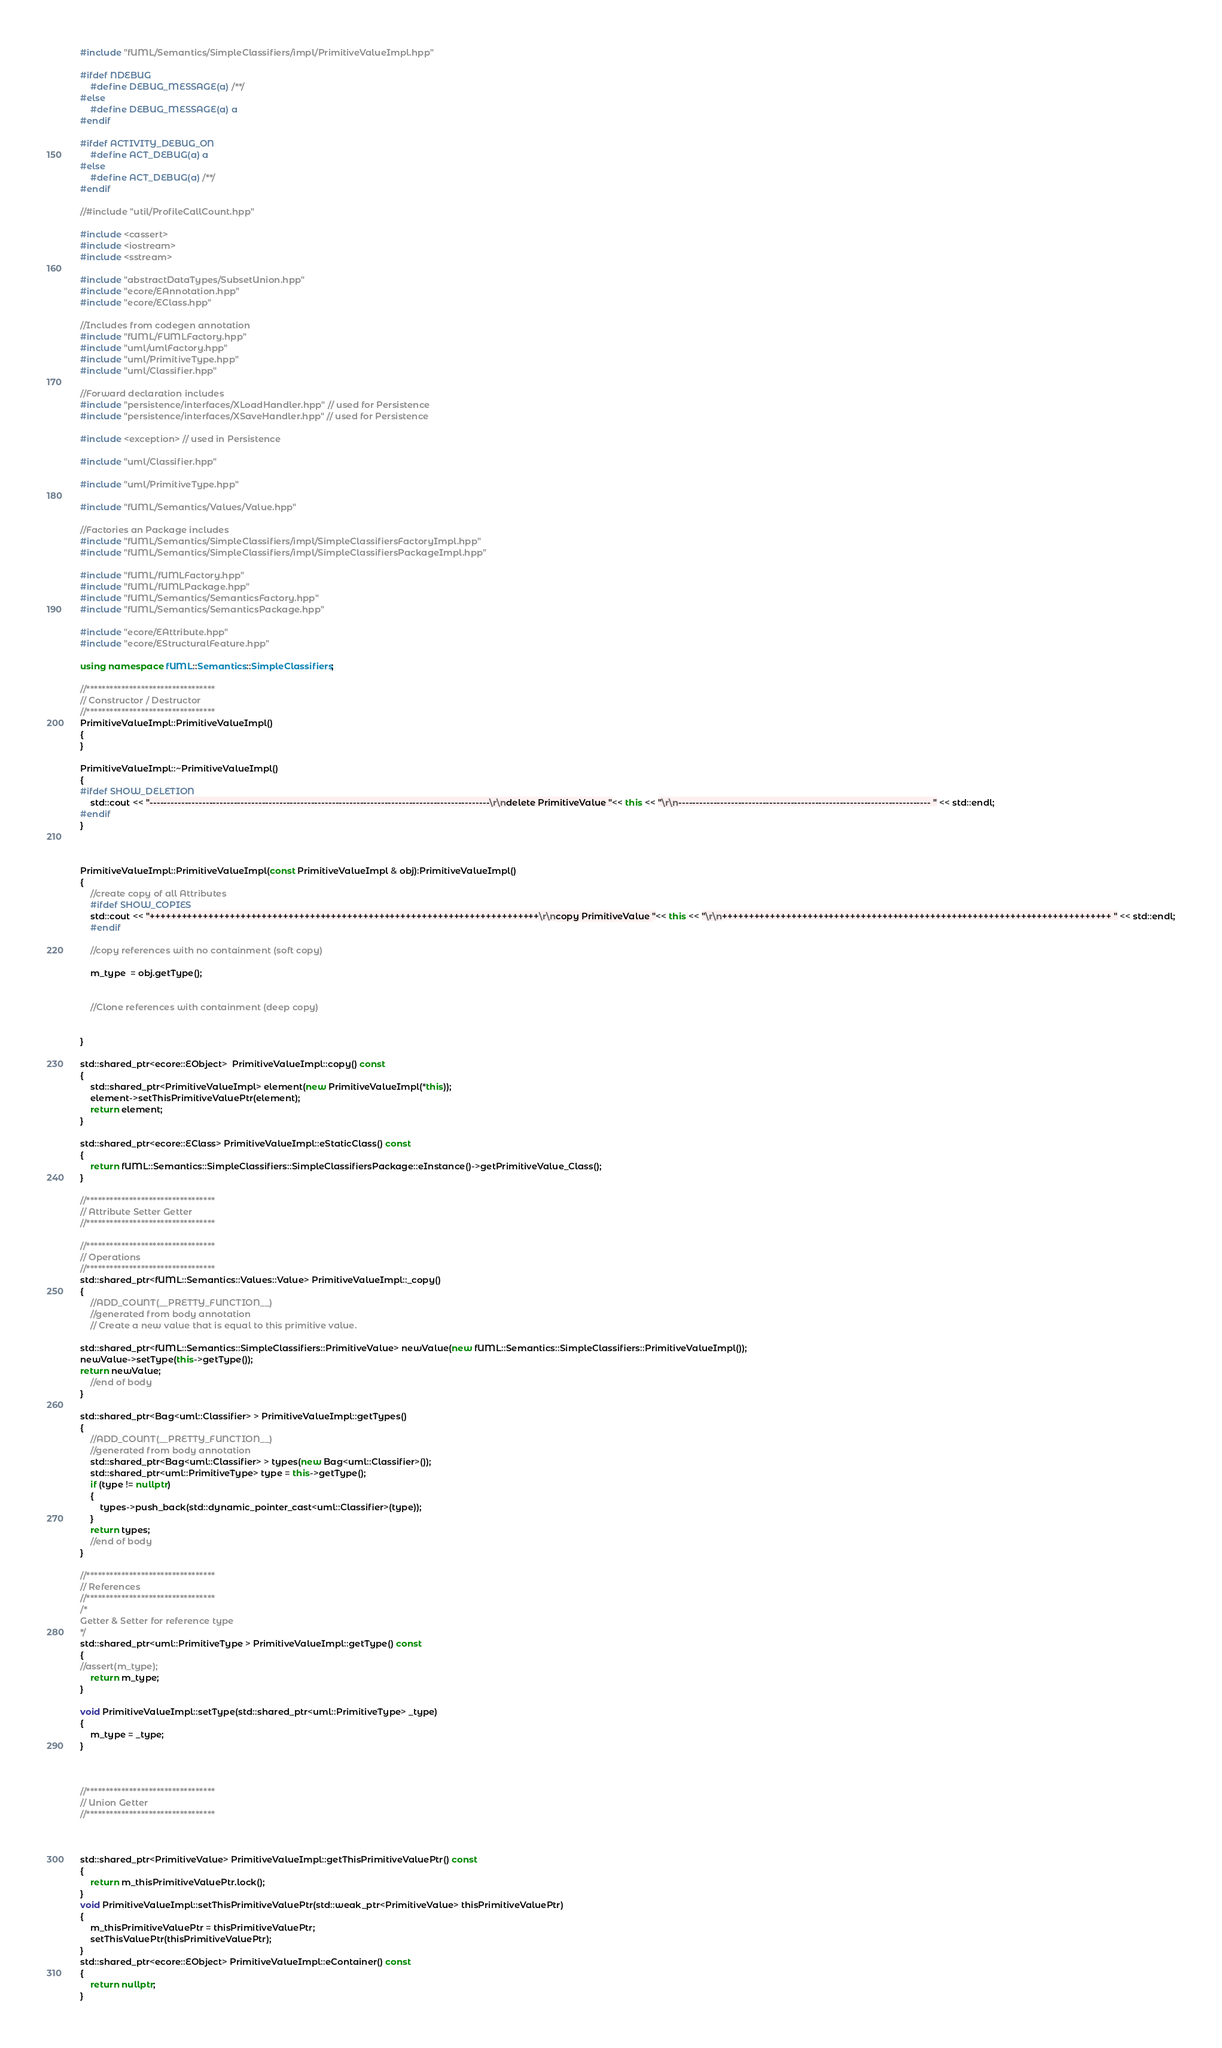<code> <loc_0><loc_0><loc_500><loc_500><_C++_>#include "fUML/Semantics/SimpleClassifiers/impl/PrimitiveValueImpl.hpp"

#ifdef NDEBUG
	#define DEBUG_MESSAGE(a) /**/
#else
	#define DEBUG_MESSAGE(a) a
#endif

#ifdef ACTIVITY_DEBUG_ON
    #define ACT_DEBUG(a) a
#else
    #define ACT_DEBUG(a) /**/
#endif

//#include "util/ProfileCallCount.hpp"

#include <cassert>
#include <iostream>
#include <sstream>

#include "abstractDataTypes/SubsetUnion.hpp"
#include "ecore/EAnnotation.hpp"
#include "ecore/EClass.hpp"

//Includes from codegen annotation
#include "fUML/FUMLFactory.hpp"
#include "uml/umlFactory.hpp"
#include "uml/PrimitiveType.hpp"
#include "uml/Classifier.hpp"

//Forward declaration includes
#include "persistence/interfaces/XLoadHandler.hpp" // used for Persistence
#include "persistence/interfaces/XSaveHandler.hpp" // used for Persistence

#include <exception> // used in Persistence

#include "uml/Classifier.hpp"

#include "uml/PrimitiveType.hpp"

#include "fUML/Semantics/Values/Value.hpp"

//Factories an Package includes
#include "fUML/Semantics/SimpleClassifiers/impl/SimpleClassifiersFactoryImpl.hpp"
#include "fUML/Semantics/SimpleClassifiers/impl/SimpleClassifiersPackageImpl.hpp"

#include "fUML/fUMLFactory.hpp"
#include "fUML/fUMLPackage.hpp"
#include "fUML/Semantics/SemanticsFactory.hpp"
#include "fUML/Semantics/SemanticsPackage.hpp"

#include "ecore/EAttribute.hpp"
#include "ecore/EStructuralFeature.hpp"

using namespace fUML::Semantics::SimpleClassifiers;

//*********************************
// Constructor / Destructor
//*********************************
PrimitiveValueImpl::PrimitiveValueImpl()
{	
}

PrimitiveValueImpl::~PrimitiveValueImpl()
{
#ifdef SHOW_DELETION
	std::cout << "-------------------------------------------------------------------------------------------------\r\ndelete PrimitiveValue "<< this << "\r\n------------------------------------------------------------------------ " << std::endl;
#endif
}



PrimitiveValueImpl::PrimitiveValueImpl(const PrimitiveValueImpl & obj):PrimitiveValueImpl()
{
	//create copy of all Attributes
	#ifdef SHOW_COPIES
	std::cout << "+++++++++++++++++++++++++++++++++++++++++++++++++++++++++++++++++++++++++\r\ncopy PrimitiveValue "<< this << "\r\n+++++++++++++++++++++++++++++++++++++++++++++++++++++++++++++++++++++++++ " << std::endl;
	#endif

	//copy references with no containment (soft copy)
	
	m_type  = obj.getType();


	//Clone references with containment (deep copy)


}

std::shared_ptr<ecore::EObject>  PrimitiveValueImpl::copy() const
{
	std::shared_ptr<PrimitiveValueImpl> element(new PrimitiveValueImpl(*this));
	element->setThisPrimitiveValuePtr(element);
	return element;
}

std::shared_ptr<ecore::EClass> PrimitiveValueImpl::eStaticClass() const
{
	return fUML::Semantics::SimpleClassifiers::SimpleClassifiersPackage::eInstance()->getPrimitiveValue_Class();
}

//*********************************
// Attribute Setter Getter
//*********************************

//*********************************
// Operations
//*********************************
std::shared_ptr<fUML::Semantics::Values::Value> PrimitiveValueImpl::_copy()
{
	//ADD_COUNT(__PRETTY_FUNCTION__)
	//generated from body annotation
	// Create a new value that is equal to this primitive value.

std::shared_ptr<fUML::Semantics::SimpleClassifiers::PrimitiveValue> newValue(new fUML::Semantics::SimpleClassifiers::PrimitiveValueImpl());
newValue->setType(this->getType());
return newValue;
	//end of body
}

std::shared_ptr<Bag<uml::Classifier> > PrimitiveValueImpl::getTypes()
{
	//ADD_COUNT(__PRETTY_FUNCTION__)
	//generated from body annotation
	std::shared_ptr<Bag<uml::Classifier> > types(new Bag<uml::Classifier>());
	std::shared_ptr<uml::PrimitiveType> type = this->getType();
	if (type != nullptr)
	{
		types->push_back(std::dynamic_pointer_cast<uml::Classifier>(type));
	}
    return types;
	//end of body
}

//*********************************
// References
//*********************************
/*
Getter & Setter for reference type
*/
std::shared_ptr<uml::PrimitiveType > PrimitiveValueImpl::getType() const
{
//assert(m_type);
    return m_type;
}

void PrimitiveValueImpl::setType(std::shared_ptr<uml::PrimitiveType> _type)
{
    m_type = _type;
}



//*********************************
// Union Getter
//*********************************



std::shared_ptr<PrimitiveValue> PrimitiveValueImpl::getThisPrimitiveValuePtr() const
{
	return m_thisPrimitiveValuePtr.lock();
}
void PrimitiveValueImpl::setThisPrimitiveValuePtr(std::weak_ptr<PrimitiveValue> thisPrimitiveValuePtr)
{
	m_thisPrimitiveValuePtr = thisPrimitiveValuePtr;
	setThisValuePtr(thisPrimitiveValuePtr);
}
std::shared_ptr<ecore::EObject> PrimitiveValueImpl::eContainer() const
{
	return nullptr;
}
</code> 